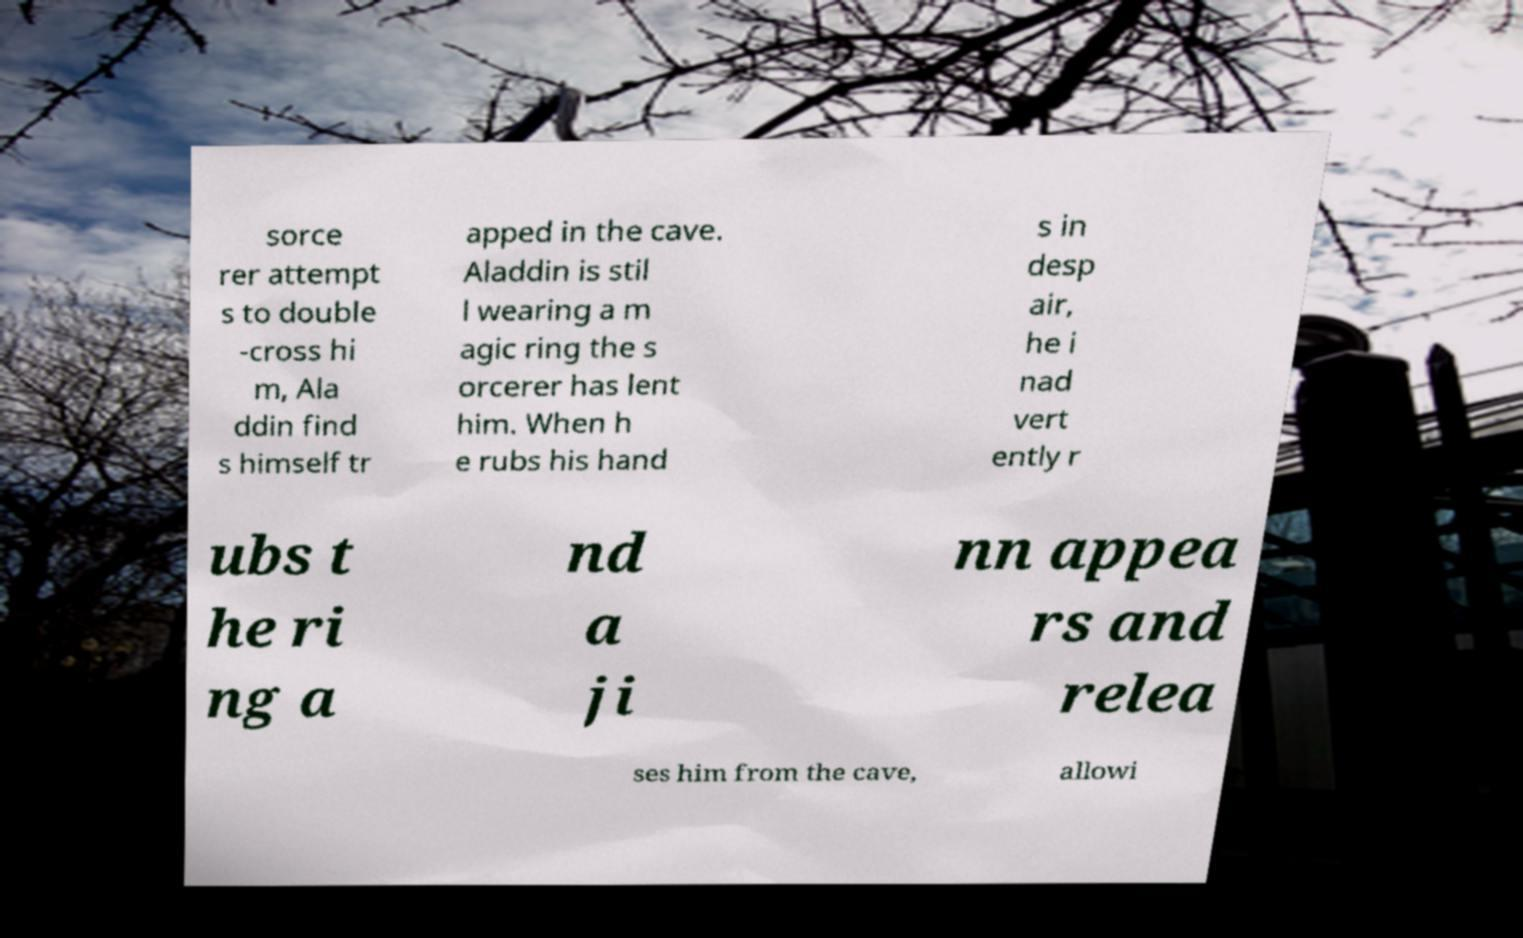Could you extract and type out the text from this image? sorce rer attempt s to double -cross hi m, Ala ddin find s himself tr apped in the cave. Aladdin is stil l wearing a m agic ring the s orcerer has lent him. When h e rubs his hand s in desp air, he i nad vert ently r ubs t he ri ng a nd a ji nn appea rs and relea ses him from the cave, allowi 